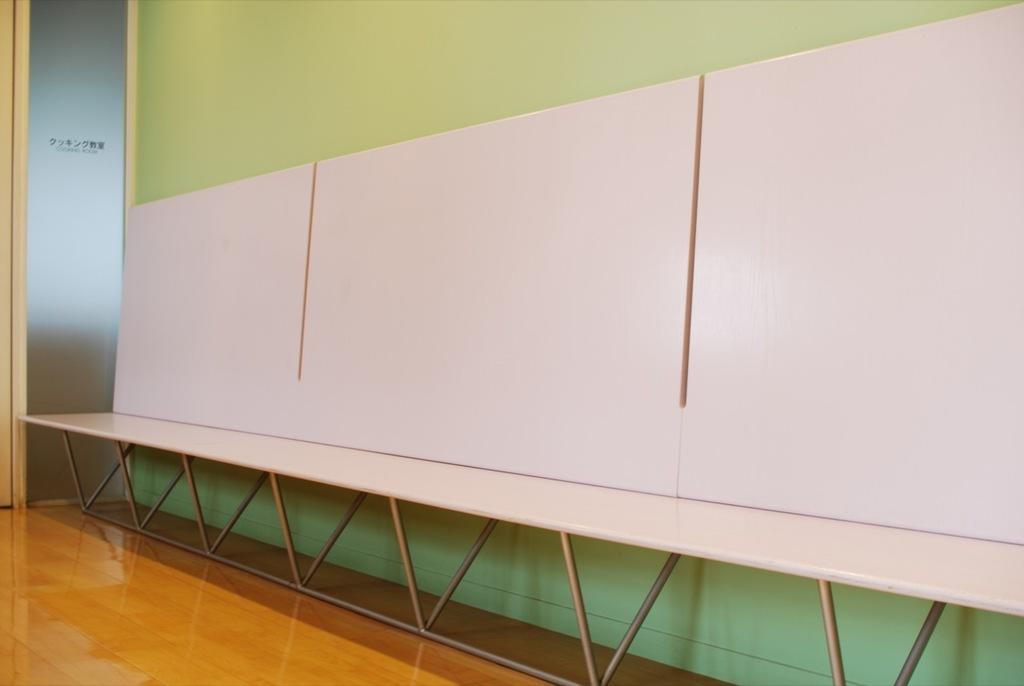What type of furniture is present in the image? There is a table in the image. What is the surface beneath the table? The table is on a wooden floor. What can be seen in the background of the image? There is a wall. What type of door is visible on the left side of the image? There is a glass door on the left side of the image. Reasoning: Let's think step by step by step in order to produce the conversation. We start by identifying the main subject in the image, which is the table. Then, we expand the conversation to include other details about the image, such as the floor, the wall in the background, and the glass door. Each question is designed to elicit a specific detail about the image that is known from the provided facts. Absurd Question/Answer: Is there an arch visible in the image? There is no arch present in the image. Is there a stage visible in the image? There is no stage present in the image. 